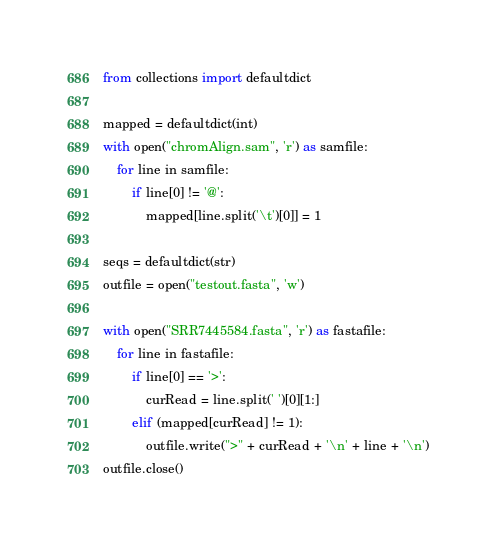<code> <loc_0><loc_0><loc_500><loc_500><_Python_>from collections import defaultdict

mapped = defaultdict(int)
with open("chromAlign.sam", 'r') as samfile:
	for line in samfile:
		if line[0] != '@':
			mapped[line.split('\t')[0]] = 1

seqs = defaultdict(str)
outfile = open("testout.fasta", 'w')

with open("SRR7445584.fasta", 'r') as fastafile:
	for line in fastafile:
		if line[0] == '>':
			curRead = line.split(' ')[0][1:]
		elif (mapped[curRead] != 1):
			outfile.write(">" + curRead + '\n' + line + '\n')
outfile.close()	
</code> 